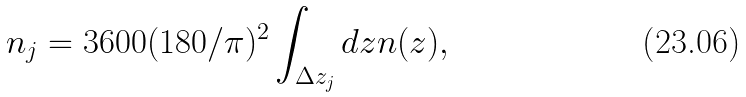<formula> <loc_0><loc_0><loc_500><loc_500>n _ { j } = 3 6 0 0 ( 1 8 0 / \pi ) ^ { 2 } \int _ { \Delta z _ { j } } d z n ( z ) ,</formula> 